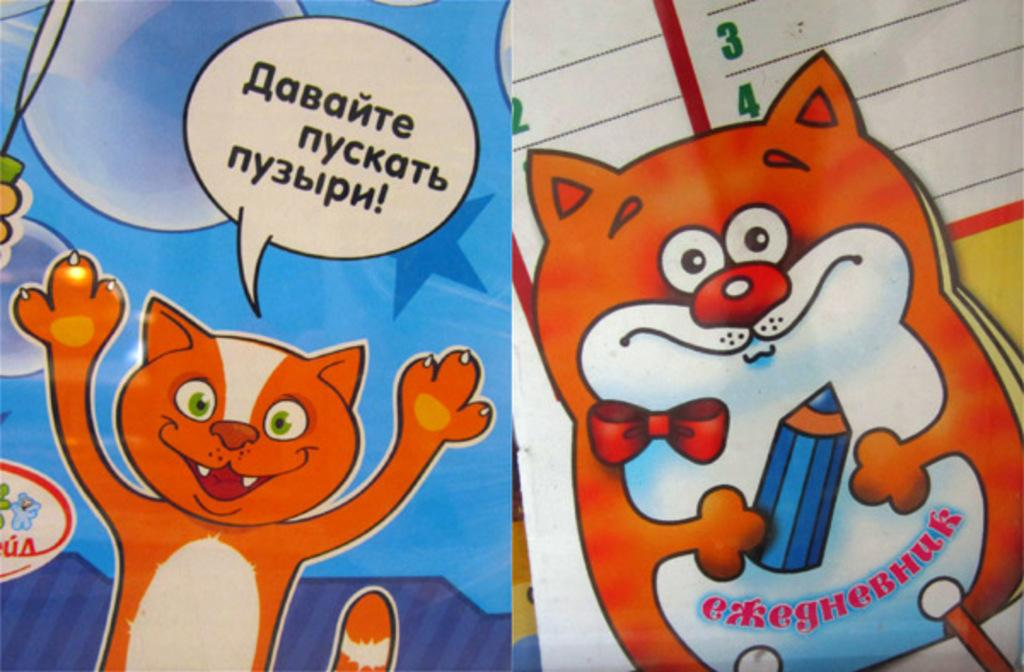What type of images are present in the image? The image contains animated images. What else can be seen in the image besides the animated images? There is some text present in the image. How many dogs are visible in the image? There are no dogs present in the image. What type of cable is used to connect the animated images to the power source? There is no cable visible in the image, as it does not provide information about the power source. What type of lettuce is used as a prop in the animated images? There is no lettuce present in the image, and it is not mentioned that any lettuce is used as a prop. 